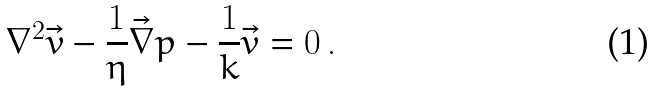Convert formula to latex. <formula><loc_0><loc_0><loc_500><loc_500>\nabla ^ { 2 } \vec { v } - \frac { 1 } { \eta } \vec { \nabla } p - \frac { 1 } { k } \vec { v } = 0 \, .</formula> 